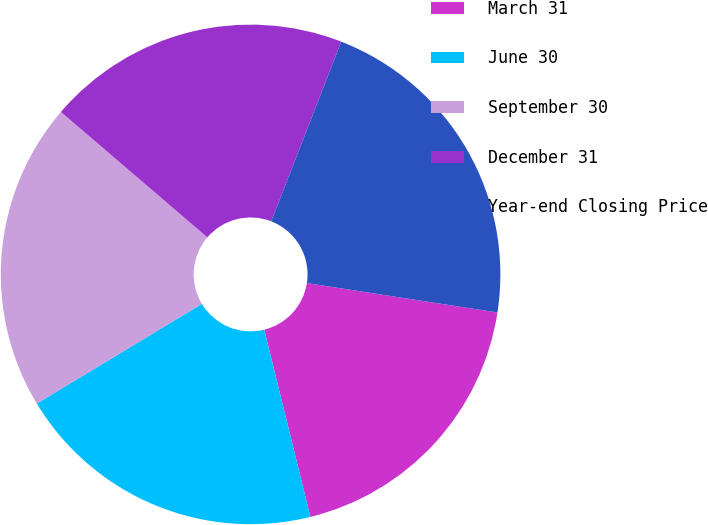Convert chart. <chart><loc_0><loc_0><loc_500><loc_500><pie_chart><fcel>March 31<fcel>June 30<fcel>September 30<fcel>December 31<fcel>Year-end Closing Price<nl><fcel>18.72%<fcel>20.2%<fcel>19.92%<fcel>19.64%<fcel>21.53%<nl></chart> 